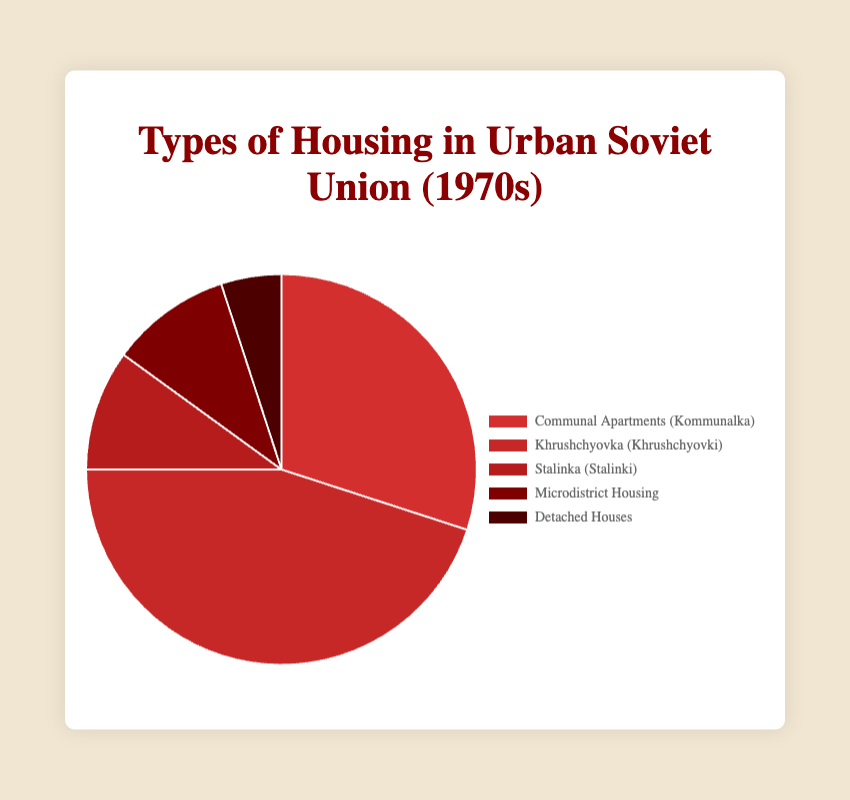What percentage of housing types in the urban Soviet Union during the 1970s were Communal Apartments (Kommunalka) and Khrushchyovka (Khrushchyovki) combined? To find the combined percentage, add the percentages of Communal Apartments (Kommunalka) and Khrushchyovka (Khrushchyovki). So, 30% + 45% = 75%.
Answer: 75% Which type of housing had the lowest percentage in the urban Soviet Union during the 1970s? By observing the percentages, Detached Houses have the lowest percentage at 5%.
Answer: Detached Houses Considering only Stalinka (Stalinki) and Microdistrict Housing, which category had a higher percentage and by how much? Stalinka and Microdistrict Housing both have 10%. So, there is no difference in percentage between the two categories.
Answer: 0% What is the difference in percentage between the most common housing type and the least common housing type? The most common housing type is Khrushchyovka (45%) and the least common is Detached Houses (5%). The difference is 45% - 5% = 40%.
Answer: 40% What percentage of the housing types were not categorized as Khrushchyovka in the 1970s? Subtract the percentage of Khrushchyovka from 100%. So, 100% - 45% = 55%.
Answer: 55% If we group Stalinka and Microdistrict Housing together, what would be their combined percentage? Add the percentages of Stalinka and Microdistrict Housing. So, 10% + 10% = 20%.
Answer: 20% What color is used to represent Khrushchyovka (Khrushchyovki) in the pie chart? Khrushchyovka is represented by a dark red color.
Answer: Dark Red Compared to Microdistrict Housing, what is the ratio of Khrushchyovka in terms of percentage? Khrushchyovka is 45%, and Microdistrict Housing is 10%. The ratio is 45% / 10% = 4.5.
Answer: 4.5 How many housing types have a percentage that is less than 20%? The housing types with less than 20% are Stalinka (10%), Microdistrict Housing (10%), and Detached Houses (5%). So, there are 3 types.
Answer: 3 